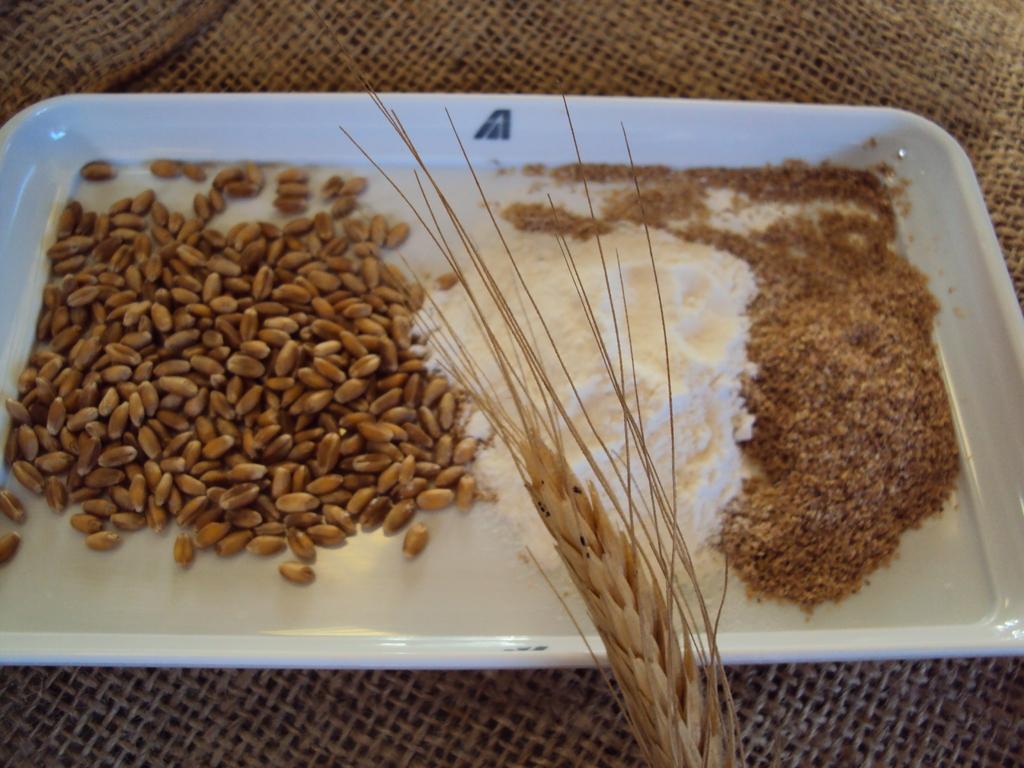Please provide a concise description of this image. In this picture we can see the seeds in a white color tray and this tray is placed on a mesh surface. 